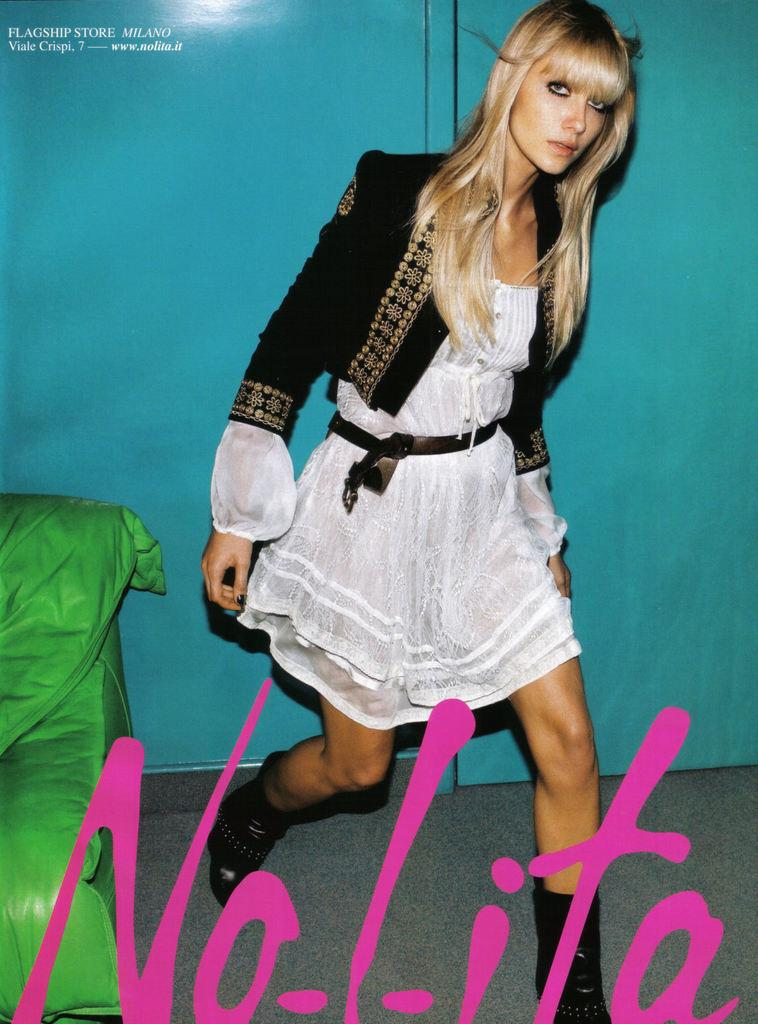Who is present in the image? There is a woman in the image. What is the woman's position in the image? The woman is on the floor in the image. What can be read or seen in the image? There is text visible in the image. What type of furniture is in the image? There is a sofa in the image. What color is the wall in the background of the image? The background of the image includes a blue wall. Where is the image likely taken? The image is likely taken in a room. What type of approval does the woman need to start the airport process in the image? There is no mention of an airport or any approval process in the image. 